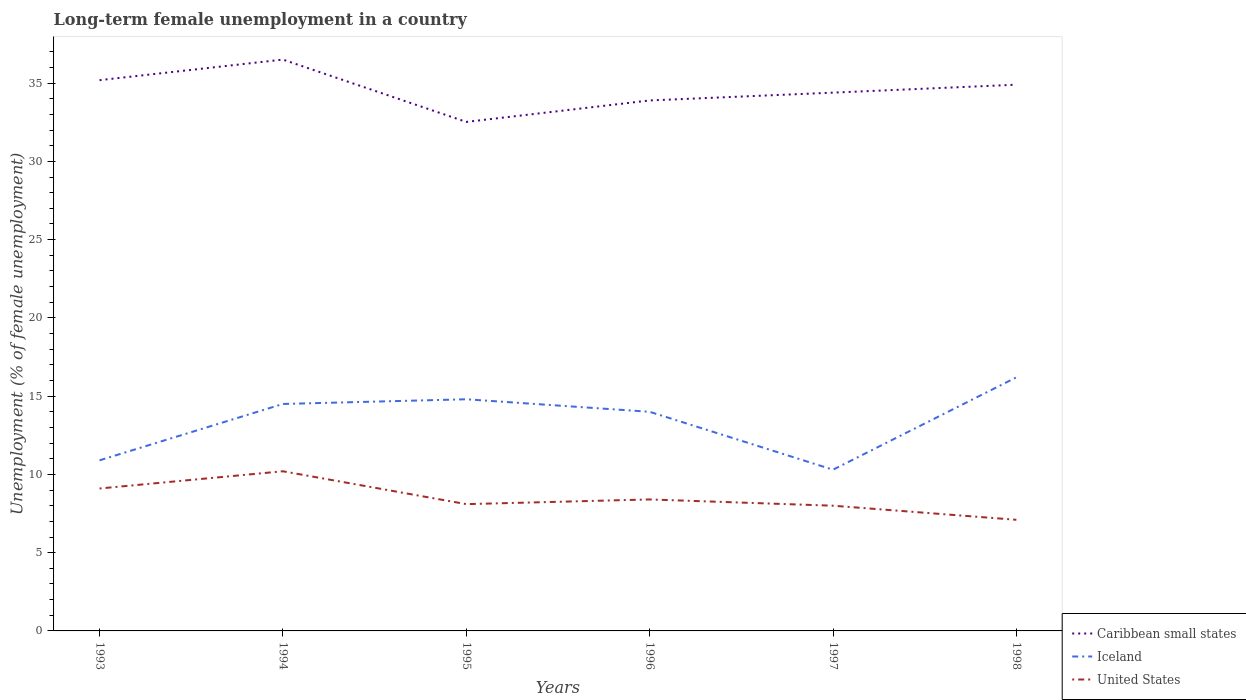Is the number of lines equal to the number of legend labels?
Offer a terse response. Yes. Across all years, what is the maximum percentage of long-term unemployed female population in Iceland?
Offer a very short reply. 10.3. What is the total percentage of long-term unemployed female population in United States in the graph?
Offer a terse response. 1.3. What is the difference between the highest and the second highest percentage of long-term unemployed female population in Caribbean small states?
Ensure brevity in your answer.  3.98. How many lines are there?
Make the answer very short. 3. How many years are there in the graph?
Ensure brevity in your answer.  6. What is the difference between two consecutive major ticks on the Y-axis?
Your answer should be very brief. 5. Are the values on the major ticks of Y-axis written in scientific E-notation?
Offer a terse response. No. Does the graph contain grids?
Provide a short and direct response. No. How many legend labels are there?
Offer a terse response. 3. How are the legend labels stacked?
Give a very brief answer. Vertical. What is the title of the graph?
Your answer should be compact. Long-term female unemployment in a country. Does "Singapore" appear as one of the legend labels in the graph?
Your response must be concise. No. What is the label or title of the Y-axis?
Ensure brevity in your answer.  Unemployment (% of female unemployment). What is the Unemployment (% of female unemployment) in Caribbean small states in 1993?
Your response must be concise. 35.19. What is the Unemployment (% of female unemployment) in Iceland in 1993?
Make the answer very short. 10.9. What is the Unemployment (% of female unemployment) in United States in 1993?
Your answer should be very brief. 9.1. What is the Unemployment (% of female unemployment) of Caribbean small states in 1994?
Give a very brief answer. 36.5. What is the Unemployment (% of female unemployment) of Iceland in 1994?
Make the answer very short. 14.5. What is the Unemployment (% of female unemployment) in United States in 1994?
Provide a short and direct response. 10.2. What is the Unemployment (% of female unemployment) in Caribbean small states in 1995?
Keep it short and to the point. 32.52. What is the Unemployment (% of female unemployment) of Iceland in 1995?
Offer a very short reply. 14.8. What is the Unemployment (% of female unemployment) of United States in 1995?
Your response must be concise. 8.1. What is the Unemployment (% of female unemployment) in Caribbean small states in 1996?
Give a very brief answer. 33.89. What is the Unemployment (% of female unemployment) of United States in 1996?
Provide a short and direct response. 8.4. What is the Unemployment (% of female unemployment) of Caribbean small states in 1997?
Your answer should be very brief. 34.39. What is the Unemployment (% of female unemployment) of Iceland in 1997?
Offer a terse response. 10.3. What is the Unemployment (% of female unemployment) in United States in 1997?
Give a very brief answer. 8. What is the Unemployment (% of female unemployment) in Caribbean small states in 1998?
Give a very brief answer. 34.9. What is the Unemployment (% of female unemployment) in Iceland in 1998?
Keep it short and to the point. 16.2. What is the Unemployment (% of female unemployment) in United States in 1998?
Provide a succinct answer. 7.1. Across all years, what is the maximum Unemployment (% of female unemployment) of Caribbean small states?
Provide a short and direct response. 36.5. Across all years, what is the maximum Unemployment (% of female unemployment) of Iceland?
Ensure brevity in your answer.  16.2. Across all years, what is the maximum Unemployment (% of female unemployment) of United States?
Make the answer very short. 10.2. Across all years, what is the minimum Unemployment (% of female unemployment) in Caribbean small states?
Offer a terse response. 32.52. Across all years, what is the minimum Unemployment (% of female unemployment) in Iceland?
Your response must be concise. 10.3. Across all years, what is the minimum Unemployment (% of female unemployment) of United States?
Your answer should be very brief. 7.1. What is the total Unemployment (% of female unemployment) of Caribbean small states in the graph?
Keep it short and to the point. 207.39. What is the total Unemployment (% of female unemployment) in Iceland in the graph?
Ensure brevity in your answer.  80.7. What is the total Unemployment (% of female unemployment) of United States in the graph?
Provide a succinct answer. 50.9. What is the difference between the Unemployment (% of female unemployment) in Caribbean small states in 1993 and that in 1994?
Give a very brief answer. -1.31. What is the difference between the Unemployment (% of female unemployment) in United States in 1993 and that in 1994?
Give a very brief answer. -1.1. What is the difference between the Unemployment (% of female unemployment) of Caribbean small states in 1993 and that in 1995?
Make the answer very short. 2.67. What is the difference between the Unemployment (% of female unemployment) of Iceland in 1993 and that in 1995?
Keep it short and to the point. -3.9. What is the difference between the Unemployment (% of female unemployment) of United States in 1993 and that in 1995?
Provide a short and direct response. 1. What is the difference between the Unemployment (% of female unemployment) in Caribbean small states in 1993 and that in 1996?
Ensure brevity in your answer.  1.3. What is the difference between the Unemployment (% of female unemployment) of United States in 1993 and that in 1996?
Offer a terse response. 0.7. What is the difference between the Unemployment (% of female unemployment) in Caribbean small states in 1993 and that in 1997?
Make the answer very short. 0.8. What is the difference between the Unemployment (% of female unemployment) of Caribbean small states in 1993 and that in 1998?
Offer a terse response. 0.29. What is the difference between the Unemployment (% of female unemployment) of Iceland in 1993 and that in 1998?
Provide a short and direct response. -5.3. What is the difference between the Unemployment (% of female unemployment) of United States in 1993 and that in 1998?
Offer a very short reply. 2. What is the difference between the Unemployment (% of female unemployment) of Caribbean small states in 1994 and that in 1995?
Keep it short and to the point. 3.98. What is the difference between the Unemployment (% of female unemployment) in United States in 1994 and that in 1995?
Ensure brevity in your answer.  2.1. What is the difference between the Unemployment (% of female unemployment) of Caribbean small states in 1994 and that in 1996?
Make the answer very short. 2.61. What is the difference between the Unemployment (% of female unemployment) in Caribbean small states in 1994 and that in 1997?
Provide a succinct answer. 2.11. What is the difference between the Unemployment (% of female unemployment) in Caribbean small states in 1994 and that in 1998?
Offer a terse response. 1.6. What is the difference between the Unemployment (% of female unemployment) of Iceland in 1994 and that in 1998?
Offer a terse response. -1.7. What is the difference between the Unemployment (% of female unemployment) in United States in 1994 and that in 1998?
Offer a terse response. 3.1. What is the difference between the Unemployment (% of female unemployment) of Caribbean small states in 1995 and that in 1996?
Keep it short and to the point. -1.37. What is the difference between the Unemployment (% of female unemployment) in United States in 1995 and that in 1996?
Offer a very short reply. -0.3. What is the difference between the Unemployment (% of female unemployment) in Caribbean small states in 1995 and that in 1997?
Make the answer very short. -1.87. What is the difference between the Unemployment (% of female unemployment) in Iceland in 1995 and that in 1997?
Your answer should be compact. 4.5. What is the difference between the Unemployment (% of female unemployment) in United States in 1995 and that in 1997?
Your response must be concise. 0.1. What is the difference between the Unemployment (% of female unemployment) in Caribbean small states in 1995 and that in 1998?
Give a very brief answer. -2.38. What is the difference between the Unemployment (% of female unemployment) in Iceland in 1995 and that in 1998?
Keep it short and to the point. -1.4. What is the difference between the Unemployment (% of female unemployment) in United States in 1995 and that in 1998?
Ensure brevity in your answer.  1. What is the difference between the Unemployment (% of female unemployment) of Caribbean small states in 1996 and that in 1997?
Offer a terse response. -0.5. What is the difference between the Unemployment (% of female unemployment) of United States in 1996 and that in 1997?
Give a very brief answer. 0.4. What is the difference between the Unemployment (% of female unemployment) in Caribbean small states in 1996 and that in 1998?
Keep it short and to the point. -1.01. What is the difference between the Unemployment (% of female unemployment) in Iceland in 1996 and that in 1998?
Your answer should be very brief. -2.2. What is the difference between the Unemployment (% of female unemployment) of Caribbean small states in 1997 and that in 1998?
Make the answer very short. -0.51. What is the difference between the Unemployment (% of female unemployment) of Iceland in 1997 and that in 1998?
Your answer should be compact. -5.9. What is the difference between the Unemployment (% of female unemployment) of Caribbean small states in 1993 and the Unemployment (% of female unemployment) of Iceland in 1994?
Your answer should be very brief. 20.69. What is the difference between the Unemployment (% of female unemployment) of Caribbean small states in 1993 and the Unemployment (% of female unemployment) of United States in 1994?
Keep it short and to the point. 24.99. What is the difference between the Unemployment (% of female unemployment) in Iceland in 1993 and the Unemployment (% of female unemployment) in United States in 1994?
Ensure brevity in your answer.  0.7. What is the difference between the Unemployment (% of female unemployment) in Caribbean small states in 1993 and the Unemployment (% of female unemployment) in Iceland in 1995?
Ensure brevity in your answer.  20.39. What is the difference between the Unemployment (% of female unemployment) of Caribbean small states in 1993 and the Unemployment (% of female unemployment) of United States in 1995?
Your answer should be very brief. 27.09. What is the difference between the Unemployment (% of female unemployment) of Caribbean small states in 1993 and the Unemployment (% of female unemployment) of Iceland in 1996?
Provide a short and direct response. 21.19. What is the difference between the Unemployment (% of female unemployment) of Caribbean small states in 1993 and the Unemployment (% of female unemployment) of United States in 1996?
Give a very brief answer. 26.79. What is the difference between the Unemployment (% of female unemployment) in Caribbean small states in 1993 and the Unemployment (% of female unemployment) in Iceland in 1997?
Your answer should be compact. 24.89. What is the difference between the Unemployment (% of female unemployment) in Caribbean small states in 1993 and the Unemployment (% of female unemployment) in United States in 1997?
Make the answer very short. 27.19. What is the difference between the Unemployment (% of female unemployment) of Caribbean small states in 1993 and the Unemployment (% of female unemployment) of Iceland in 1998?
Provide a succinct answer. 18.99. What is the difference between the Unemployment (% of female unemployment) in Caribbean small states in 1993 and the Unemployment (% of female unemployment) in United States in 1998?
Your answer should be very brief. 28.09. What is the difference between the Unemployment (% of female unemployment) in Iceland in 1993 and the Unemployment (% of female unemployment) in United States in 1998?
Make the answer very short. 3.8. What is the difference between the Unemployment (% of female unemployment) in Caribbean small states in 1994 and the Unemployment (% of female unemployment) in Iceland in 1995?
Keep it short and to the point. 21.7. What is the difference between the Unemployment (% of female unemployment) of Caribbean small states in 1994 and the Unemployment (% of female unemployment) of United States in 1995?
Give a very brief answer. 28.4. What is the difference between the Unemployment (% of female unemployment) in Iceland in 1994 and the Unemployment (% of female unemployment) in United States in 1995?
Make the answer very short. 6.4. What is the difference between the Unemployment (% of female unemployment) in Caribbean small states in 1994 and the Unemployment (% of female unemployment) in Iceland in 1996?
Keep it short and to the point. 22.5. What is the difference between the Unemployment (% of female unemployment) in Caribbean small states in 1994 and the Unemployment (% of female unemployment) in United States in 1996?
Keep it short and to the point. 28.1. What is the difference between the Unemployment (% of female unemployment) of Caribbean small states in 1994 and the Unemployment (% of female unemployment) of Iceland in 1997?
Keep it short and to the point. 26.2. What is the difference between the Unemployment (% of female unemployment) of Caribbean small states in 1994 and the Unemployment (% of female unemployment) of United States in 1997?
Your answer should be very brief. 28.5. What is the difference between the Unemployment (% of female unemployment) of Iceland in 1994 and the Unemployment (% of female unemployment) of United States in 1997?
Provide a succinct answer. 6.5. What is the difference between the Unemployment (% of female unemployment) of Caribbean small states in 1994 and the Unemployment (% of female unemployment) of Iceland in 1998?
Your response must be concise. 20.3. What is the difference between the Unemployment (% of female unemployment) of Caribbean small states in 1994 and the Unemployment (% of female unemployment) of United States in 1998?
Offer a terse response. 29.4. What is the difference between the Unemployment (% of female unemployment) in Caribbean small states in 1995 and the Unemployment (% of female unemployment) in Iceland in 1996?
Provide a succinct answer. 18.52. What is the difference between the Unemployment (% of female unemployment) in Caribbean small states in 1995 and the Unemployment (% of female unemployment) in United States in 1996?
Keep it short and to the point. 24.12. What is the difference between the Unemployment (% of female unemployment) in Iceland in 1995 and the Unemployment (% of female unemployment) in United States in 1996?
Keep it short and to the point. 6.4. What is the difference between the Unemployment (% of female unemployment) of Caribbean small states in 1995 and the Unemployment (% of female unemployment) of Iceland in 1997?
Offer a very short reply. 22.22. What is the difference between the Unemployment (% of female unemployment) of Caribbean small states in 1995 and the Unemployment (% of female unemployment) of United States in 1997?
Ensure brevity in your answer.  24.52. What is the difference between the Unemployment (% of female unemployment) in Caribbean small states in 1995 and the Unemployment (% of female unemployment) in Iceland in 1998?
Your answer should be very brief. 16.32. What is the difference between the Unemployment (% of female unemployment) of Caribbean small states in 1995 and the Unemployment (% of female unemployment) of United States in 1998?
Your answer should be very brief. 25.42. What is the difference between the Unemployment (% of female unemployment) in Iceland in 1995 and the Unemployment (% of female unemployment) in United States in 1998?
Provide a succinct answer. 7.7. What is the difference between the Unemployment (% of female unemployment) of Caribbean small states in 1996 and the Unemployment (% of female unemployment) of Iceland in 1997?
Ensure brevity in your answer.  23.59. What is the difference between the Unemployment (% of female unemployment) of Caribbean small states in 1996 and the Unemployment (% of female unemployment) of United States in 1997?
Ensure brevity in your answer.  25.89. What is the difference between the Unemployment (% of female unemployment) of Iceland in 1996 and the Unemployment (% of female unemployment) of United States in 1997?
Offer a terse response. 6. What is the difference between the Unemployment (% of female unemployment) of Caribbean small states in 1996 and the Unemployment (% of female unemployment) of Iceland in 1998?
Your response must be concise. 17.69. What is the difference between the Unemployment (% of female unemployment) of Caribbean small states in 1996 and the Unemployment (% of female unemployment) of United States in 1998?
Keep it short and to the point. 26.79. What is the difference between the Unemployment (% of female unemployment) of Caribbean small states in 1997 and the Unemployment (% of female unemployment) of Iceland in 1998?
Provide a short and direct response. 18.19. What is the difference between the Unemployment (% of female unemployment) in Caribbean small states in 1997 and the Unemployment (% of female unemployment) in United States in 1998?
Your answer should be very brief. 27.29. What is the average Unemployment (% of female unemployment) in Caribbean small states per year?
Give a very brief answer. 34.57. What is the average Unemployment (% of female unemployment) in Iceland per year?
Provide a short and direct response. 13.45. What is the average Unemployment (% of female unemployment) of United States per year?
Keep it short and to the point. 8.48. In the year 1993, what is the difference between the Unemployment (% of female unemployment) in Caribbean small states and Unemployment (% of female unemployment) in Iceland?
Provide a short and direct response. 24.29. In the year 1993, what is the difference between the Unemployment (% of female unemployment) of Caribbean small states and Unemployment (% of female unemployment) of United States?
Ensure brevity in your answer.  26.09. In the year 1994, what is the difference between the Unemployment (% of female unemployment) in Caribbean small states and Unemployment (% of female unemployment) in Iceland?
Make the answer very short. 22. In the year 1994, what is the difference between the Unemployment (% of female unemployment) of Caribbean small states and Unemployment (% of female unemployment) of United States?
Your answer should be compact. 26.3. In the year 1995, what is the difference between the Unemployment (% of female unemployment) of Caribbean small states and Unemployment (% of female unemployment) of Iceland?
Ensure brevity in your answer.  17.72. In the year 1995, what is the difference between the Unemployment (% of female unemployment) of Caribbean small states and Unemployment (% of female unemployment) of United States?
Provide a succinct answer. 24.42. In the year 1996, what is the difference between the Unemployment (% of female unemployment) of Caribbean small states and Unemployment (% of female unemployment) of Iceland?
Provide a succinct answer. 19.89. In the year 1996, what is the difference between the Unemployment (% of female unemployment) of Caribbean small states and Unemployment (% of female unemployment) of United States?
Offer a very short reply. 25.49. In the year 1996, what is the difference between the Unemployment (% of female unemployment) in Iceland and Unemployment (% of female unemployment) in United States?
Your answer should be very brief. 5.6. In the year 1997, what is the difference between the Unemployment (% of female unemployment) of Caribbean small states and Unemployment (% of female unemployment) of Iceland?
Offer a very short reply. 24.09. In the year 1997, what is the difference between the Unemployment (% of female unemployment) of Caribbean small states and Unemployment (% of female unemployment) of United States?
Make the answer very short. 26.39. In the year 1997, what is the difference between the Unemployment (% of female unemployment) in Iceland and Unemployment (% of female unemployment) in United States?
Offer a very short reply. 2.3. In the year 1998, what is the difference between the Unemployment (% of female unemployment) of Caribbean small states and Unemployment (% of female unemployment) of Iceland?
Offer a very short reply. 18.7. In the year 1998, what is the difference between the Unemployment (% of female unemployment) of Caribbean small states and Unemployment (% of female unemployment) of United States?
Keep it short and to the point. 27.8. In the year 1998, what is the difference between the Unemployment (% of female unemployment) of Iceland and Unemployment (% of female unemployment) of United States?
Offer a very short reply. 9.1. What is the ratio of the Unemployment (% of female unemployment) in Caribbean small states in 1993 to that in 1994?
Provide a short and direct response. 0.96. What is the ratio of the Unemployment (% of female unemployment) of Iceland in 1993 to that in 1994?
Offer a very short reply. 0.75. What is the ratio of the Unemployment (% of female unemployment) in United States in 1993 to that in 1994?
Your answer should be compact. 0.89. What is the ratio of the Unemployment (% of female unemployment) of Caribbean small states in 1993 to that in 1995?
Your answer should be compact. 1.08. What is the ratio of the Unemployment (% of female unemployment) of Iceland in 1993 to that in 1995?
Give a very brief answer. 0.74. What is the ratio of the Unemployment (% of female unemployment) of United States in 1993 to that in 1995?
Offer a very short reply. 1.12. What is the ratio of the Unemployment (% of female unemployment) in Caribbean small states in 1993 to that in 1996?
Provide a short and direct response. 1.04. What is the ratio of the Unemployment (% of female unemployment) in Iceland in 1993 to that in 1996?
Your answer should be very brief. 0.78. What is the ratio of the Unemployment (% of female unemployment) of Caribbean small states in 1993 to that in 1997?
Your answer should be very brief. 1.02. What is the ratio of the Unemployment (% of female unemployment) of Iceland in 1993 to that in 1997?
Give a very brief answer. 1.06. What is the ratio of the Unemployment (% of female unemployment) in United States in 1993 to that in 1997?
Your response must be concise. 1.14. What is the ratio of the Unemployment (% of female unemployment) in Caribbean small states in 1993 to that in 1998?
Your answer should be very brief. 1.01. What is the ratio of the Unemployment (% of female unemployment) in Iceland in 1993 to that in 1998?
Ensure brevity in your answer.  0.67. What is the ratio of the Unemployment (% of female unemployment) of United States in 1993 to that in 1998?
Offer a terse response. 1.28. What is the ratio of the Unemployment (% of female unemployment) of Caribbean small states in 1994 to that in 1995?
Ensure brevity in your answer.  1.12. What is the ratio of the Unemployment (% of female unemployment) in Iceland in 1994 to that in 1995?
Give a very brief answer. 0.98. What is the ratio of the Unemployment (% of female unemployment) in United States in 1994 to that in 1995?
Give a very brief answer. 1.26. What is the ratio of the Unemployment (% of female unemployment) of Caribbean small states in 1994 to that in 1996?
Your answer should be compact. 1.08. What is the ratio of the Unemployment (% of female unemployment) of Iceland in 1994 to that in 1996?
Your response must be concise. 1.04. What is the ratio of the Unemployment (% of female unemployment) in United States in 1994 to that in 1996?
Ensure brevity in your answer.  1.21. What is the ratio of the Unemployment (% of female unemployment) of Caribbean small states in 1994 to that in 1997?
Give a very brief answer. 1.06. What is the ratio of the Unemployment (% of female unemployment) in Iceland in 1994 to that in 1997?
Your response must be concise. 1.41. What is the ratio of the Unemployment (% of female unemployment) of United States in 1994 to that in 1997?
Your response must be concise. 1.27. What is the ratio of the Unemployment (% of female unemployment) in Caribbean small states in 1994 to that in 1998?
Keep it short and to the point. 1.05. What is the ratio of the Unemployment (% of female unemployment) in Iceland in 1994 to that in 1998?
Ensure brevity in your answer.  0.9. What is the ratio of the Unemployment (% of female unemployment) of United States in 1994 to that in 1998?
Your answer should be compact. 1.44. What is the ratio of the Unemployment (% of female unemployment) in Caribbean small states in 1995 to that in 1996?
Offer a very short reply. 0.96. What is the ratio of the Unemployment (% of female unemployment) of Iceland in 1995 to that in 1996?
Offer a very short reply. 1.06. What is the ratio of the Unemployment (% of female unemployment) of Caribbean small states in 1995 to that in 1997?
Your response must be concise. 0.95. What is the ratio of the Unemployment (% of female unemployment) of Iceland in 1995 to that in 1997?
Keep it short and to the point. 1.44. What is the ratio of the Unemployment (% of female unemployment) of United States in 1995 to that in 1997?
Make the answer very short. 1.01. What is the ratio of the Unemployment (% of female unemployment) in Caribbean small states in 1995 to that in 1998?
Provide a short and direct response. 0.93. What is the ratio of the Unemployment (% of female unemployment) in Iceland in 1995 to that in 1998?
Your answer should be very brief. 0.91. What is the ratio of the Unemployment (% of female unemployment) in United States in 1995 to that in 1998?
Your answer should be very brief. 1.14. What is the ratio of the Unemployment (% of female unemployment) in Caribbean small states in 1996 to that in 1997?
Offer a very short reply. 0.99. What is the ratio of the Unemployment (% of female unemployment) in Iceland in 1996 to that in 1997?
Provide a short and direct response. 1.36. What is the ratio of the Unemployment (% of female unemployment) in United States in 1996 to that in 1997?
Make the answer very short. 1.05. What is the ratio of the Unemployment (% of female unemployment) in Caribbean small states in 1996 to that in 1998?
Offer a terse response. 0.97. What is the ratio of the Unemployment (% of female unemployment) of Iceland in 1996 to that in 1998?
Your answer should be compact. 0.86. What is the ratio of the Unemployment (% of female unemployment) of United States in 1996 to that in 1998?
Ensure brevity in your answer.  1.18. What is the ratio of the Unemployment (% of female unemployment) of Caribbean small states in 1997 to that in 1998?
Your response must be concise. 0.99. What is the ratio of the Unemployment (% of female unemployment) of Iceland in 1997 to that in 1998?
Your response must be concise. 0.64. What is the ratio of the Unemployment (% of female unemployment) in United States in 1997 to that in 1998?
Keep it short and to the point. 1.13. What is the difference between the highest and the second highest Unemployment (% of female unemployment) of Caribbean small states?
Offer a very short reply. 1.31. What is the difference between the highest and the lowest Unemployment (% of female unemployment) in Caribbean small states?
Provide a short and direct response. 3.98. What is the difference between the highest and the lowest Unemployment (% of female unemployment) in United States?
Make the answer very short. 3.1. 